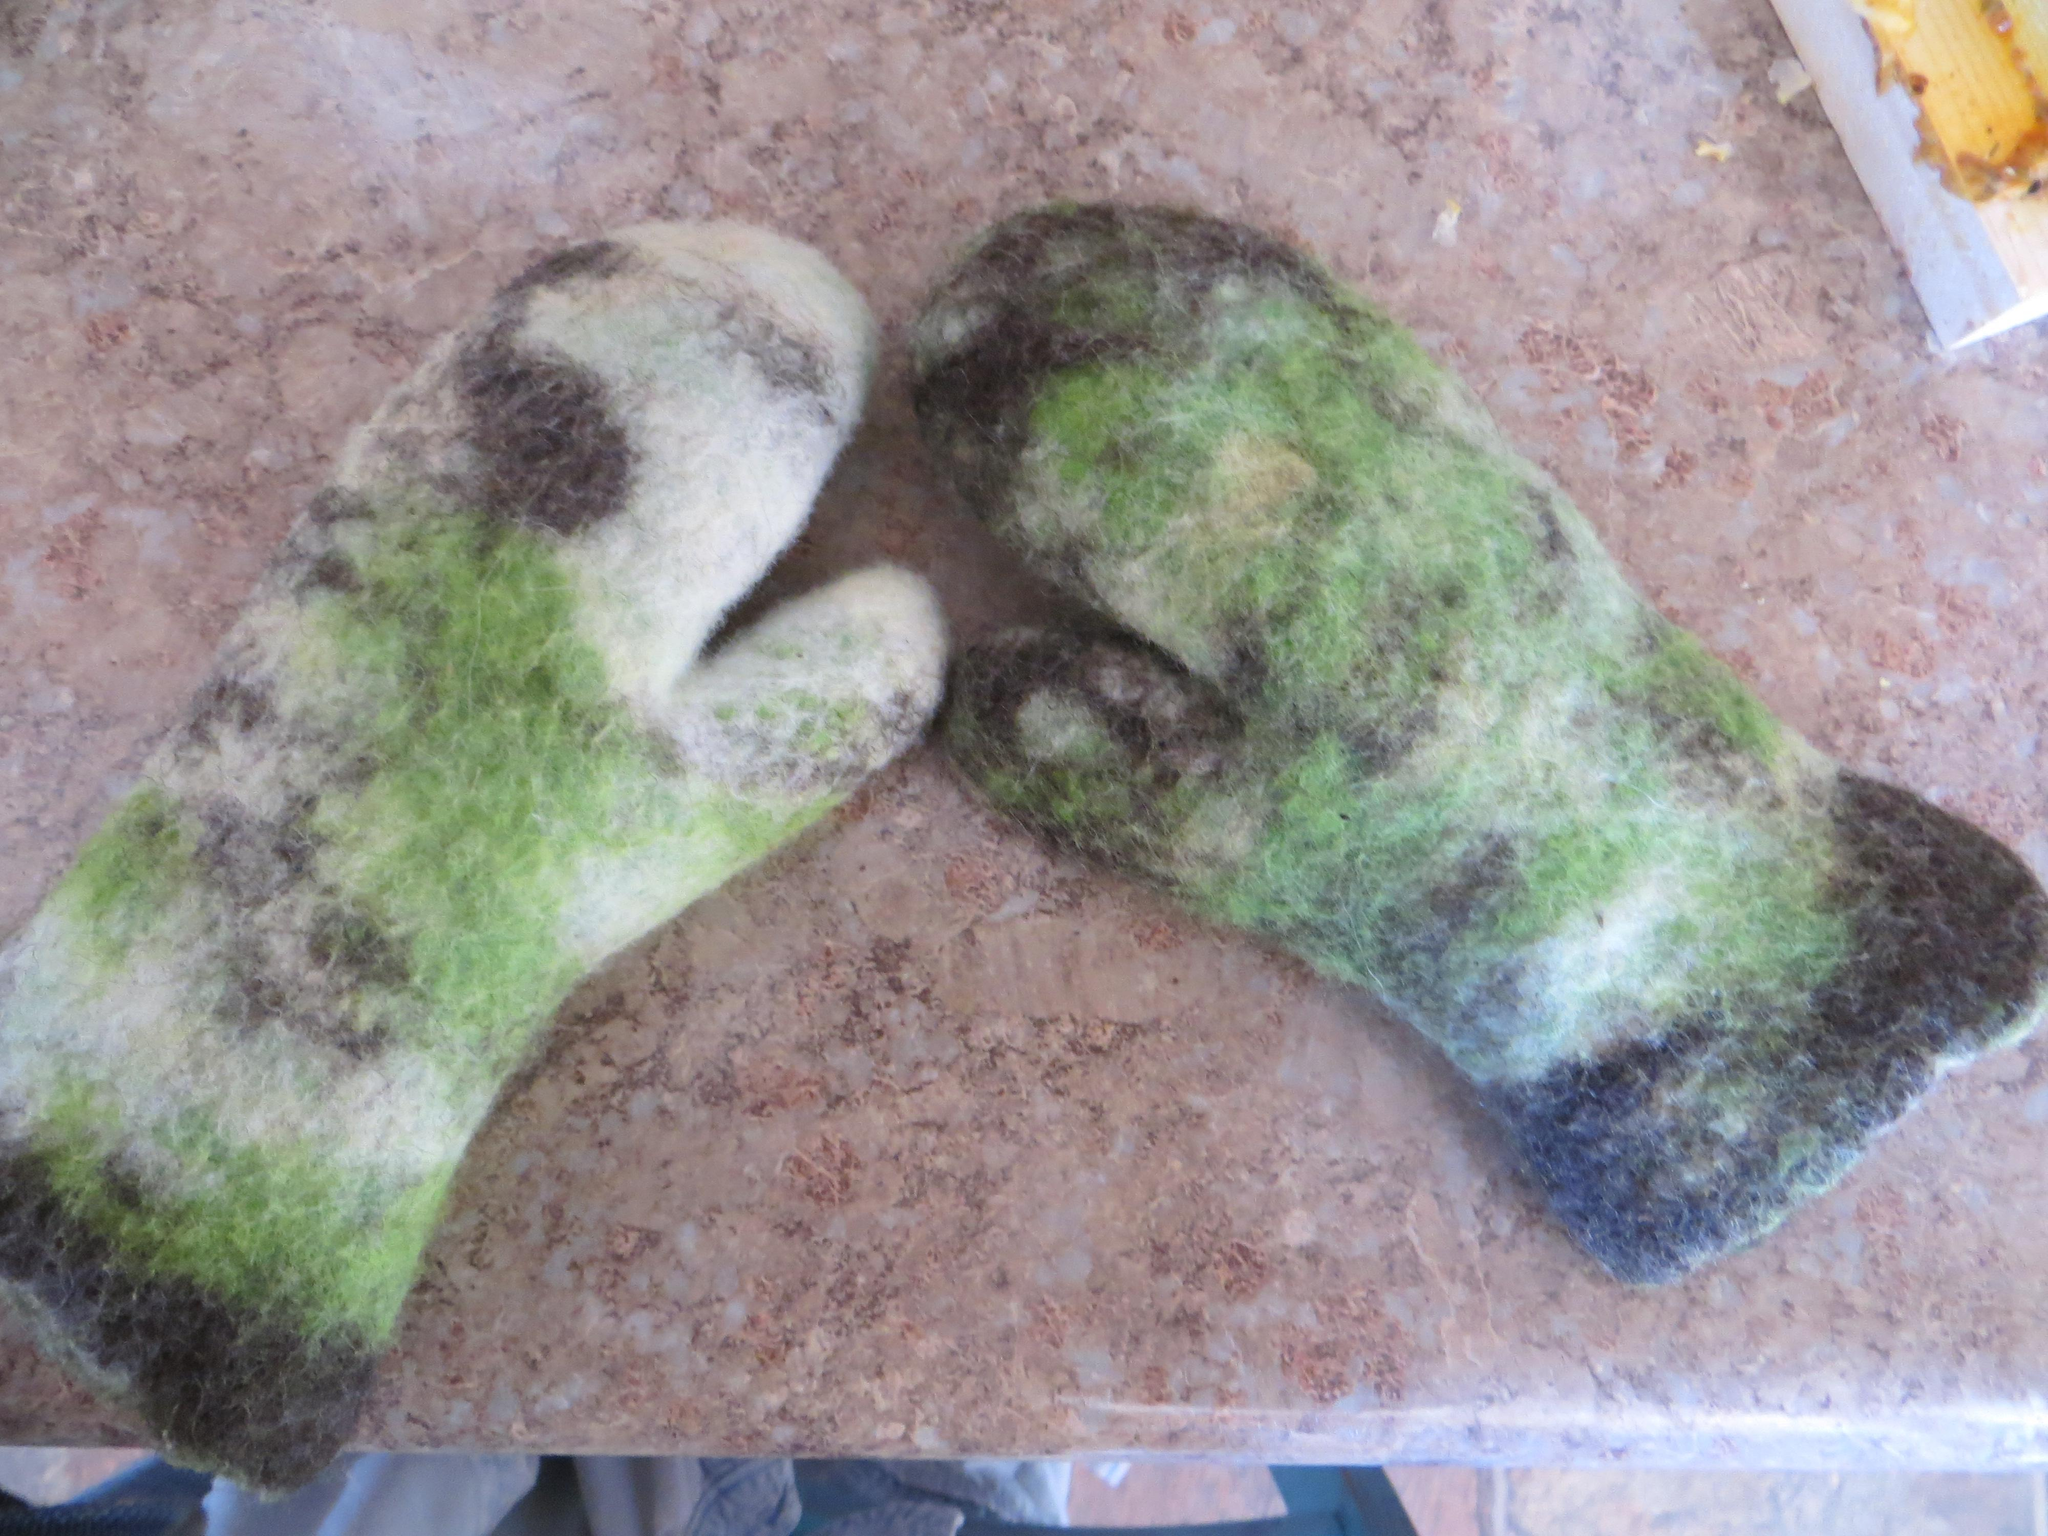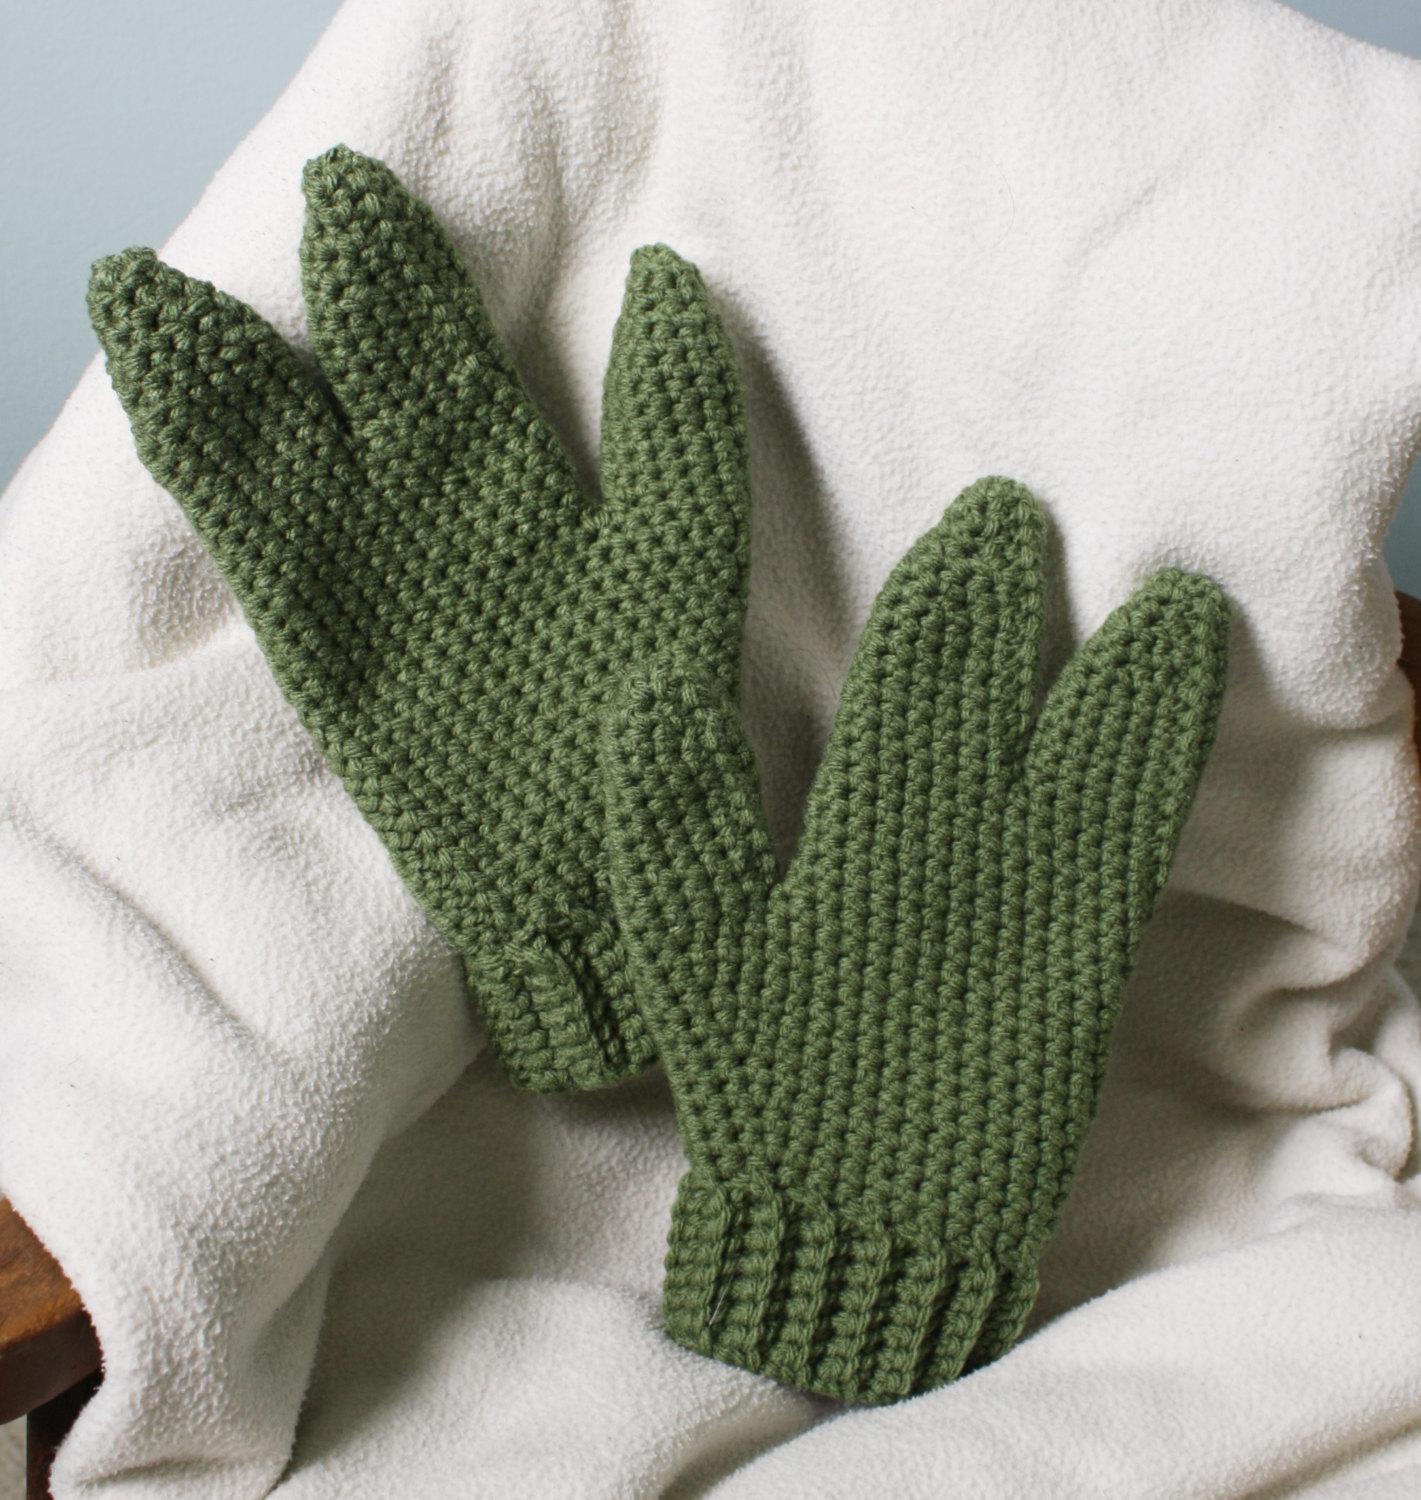The first image is the image on the left, the second image is the image on the right. For the images shown, is this caption "only ONE of the sets of gloves is green." true? Answer yes or no. No. 